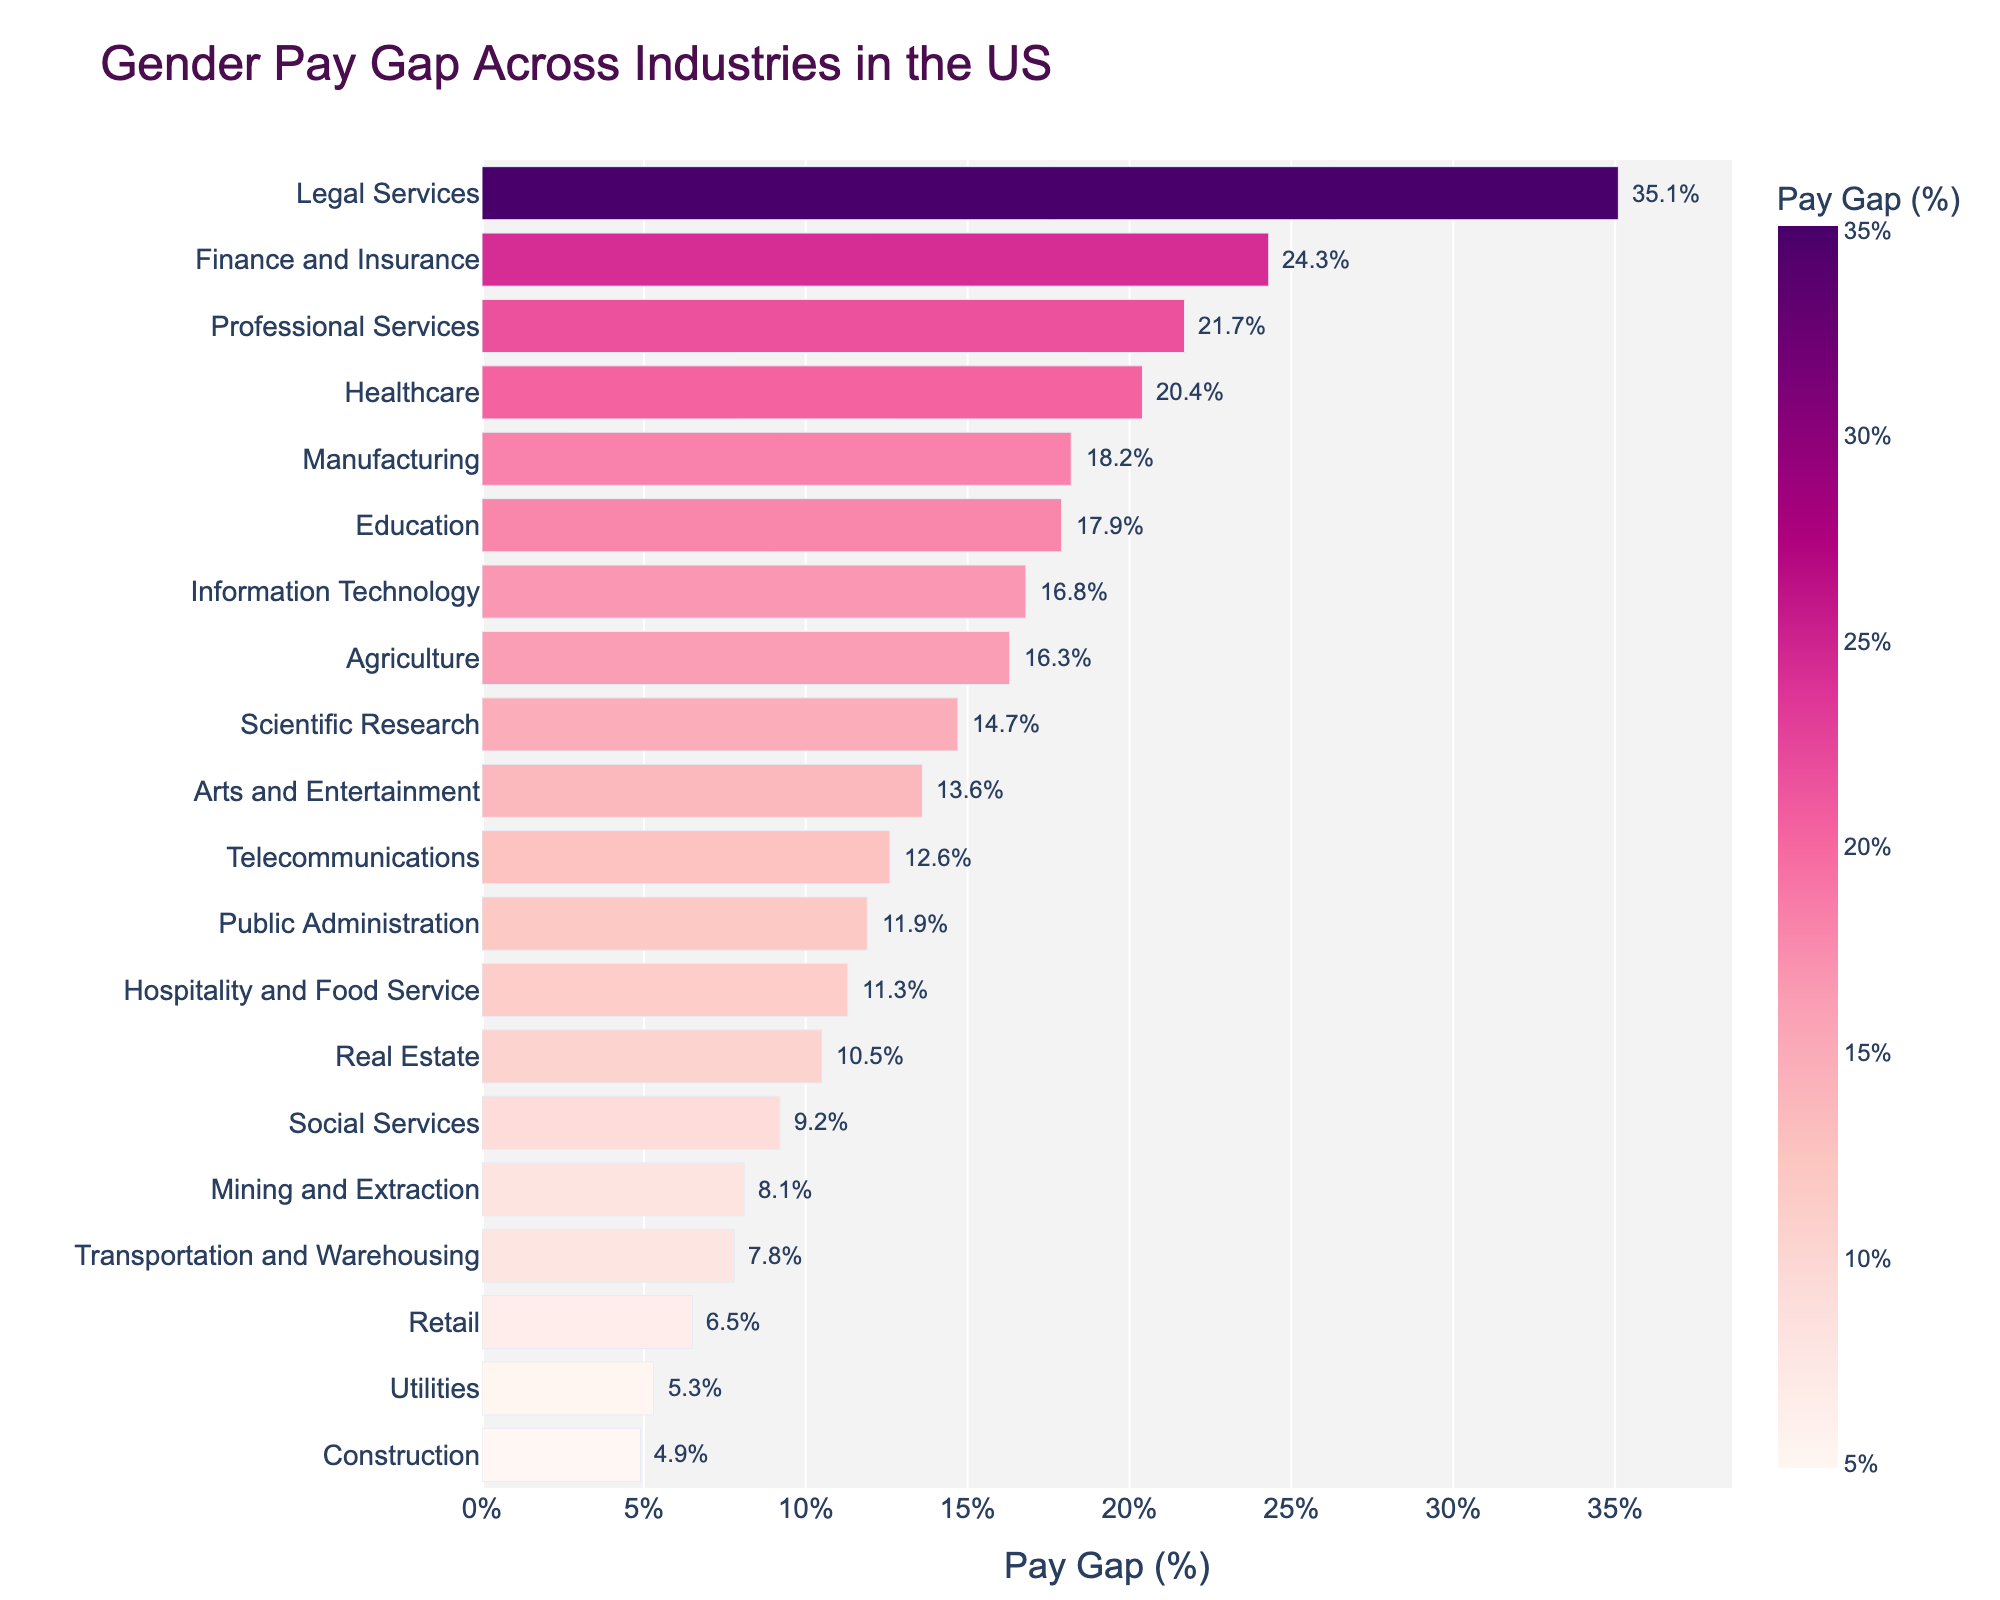Which industry has the highest gender pay gap percentage? The bar for Legal Services is the longest and has the highest percentage annotation.
Answer: Legal Services Which industry has the lowest gender pay gap percentage? The bar for Construction is the shortest and has the lowest percentage annotation.
Answer: Construction What is the average gender pay gap percentage across all industries? Sum all pay gap percentages and divide by the number of industries: (20.4 + 17.9 + 24.3 + 16.8 + 6.5 + 18.2 + 21.7 + 4.9 + 11.3 + 7.8 + 10.5 + 13.6 + 35.1 + 11.9 + 14.7 + 9.2 + 16.3 + 8.1 + 5.3 + 12.6) / 20 = 13.835
Answer: 13.8 How much greater is the gender pay gap in Finance and Insurance compared to Retail? Subtract the pay gap percentage of Retail from Finance and Insurance: 24.3 - 6.5 = 17.8%
Answer: 17.8% Which industry has a higher gender pay gap: Education or Public Administration? The bar for Education is longer with a higher percentage annotation compared to Public Administration.
Answer: Education What is the total gender pay gap percentage for the top three industries with the highest pay gaps? Add the pay gap percentages of Legal Services, Finance and Insurance, and Professional Services: 35.1 + 24.3 + 21.7 = 81.1%
Answer: 81.1% Which industry has a shorter bar, Agriculture or Telecommunications, and what does this indicate? The bar for Telecommunications is shorter than Agriculture, indicating a lower gender pay gap percentage.
Answer: Telecommunications (lower pay gap) Is the pay gap percentage in Manufacturing greater than or less than the average pay gap percentage across all industries? The pay gap percentage in Manufacturing (18.2%) is greater than the average pay gap percentage across all industries (13.8%).
Answer: Greater By how much does the gender pay gap in Legal Services exceed that in Information Technology? Subtract the pay gap percentage of Information Technology from Legal Services: 35.1 - 16.8 = 18.3%
Answer: 18.3% What is the combined pay gap percentage for the industries in the Technology sector: Information Technology and Telecommunications? Add the pay gap percentages of Information Technology and Telecommunications: 16.8 + 12.6 = 29.4%
Answer: 29.4% 